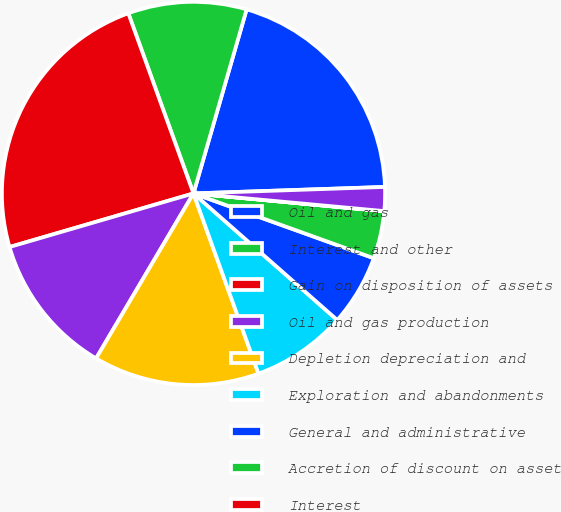Convert chart. <chart><loc_0><loc_0><loc_500><loc_500><pie_chart><fcel>Oil and gas<fcel>Interest and other<fcel>Gain on disposition of assets<fcel>Oil and gas production<fcel>Depletion depreciation and<fcel>Exploration and abandonments<fcel>General and administrative<fcel>Accretion of discount on asset<fcel>Interest<fcel>Other<nl><fcel>19.99%<fcel>10.0%<fcel>23.99%<fcel>12.0%<fcel>14.0%<fcel>8.0%<fcel>6.0%<fcel>4.01%<fcel>0.01%<fcel>2.01%<nl></chart> 